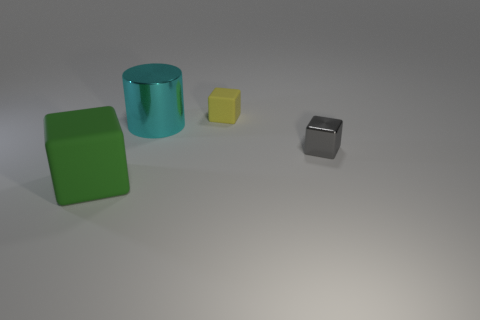What is the shape of the small gray thing that is the same material as the cyan cylinder? The small gray object, which appears to have the same smooth and matte finish as the cyan cylinder, is shaped like a cube. A cube is a three-dimensional geometric figure with six equal square faces. 